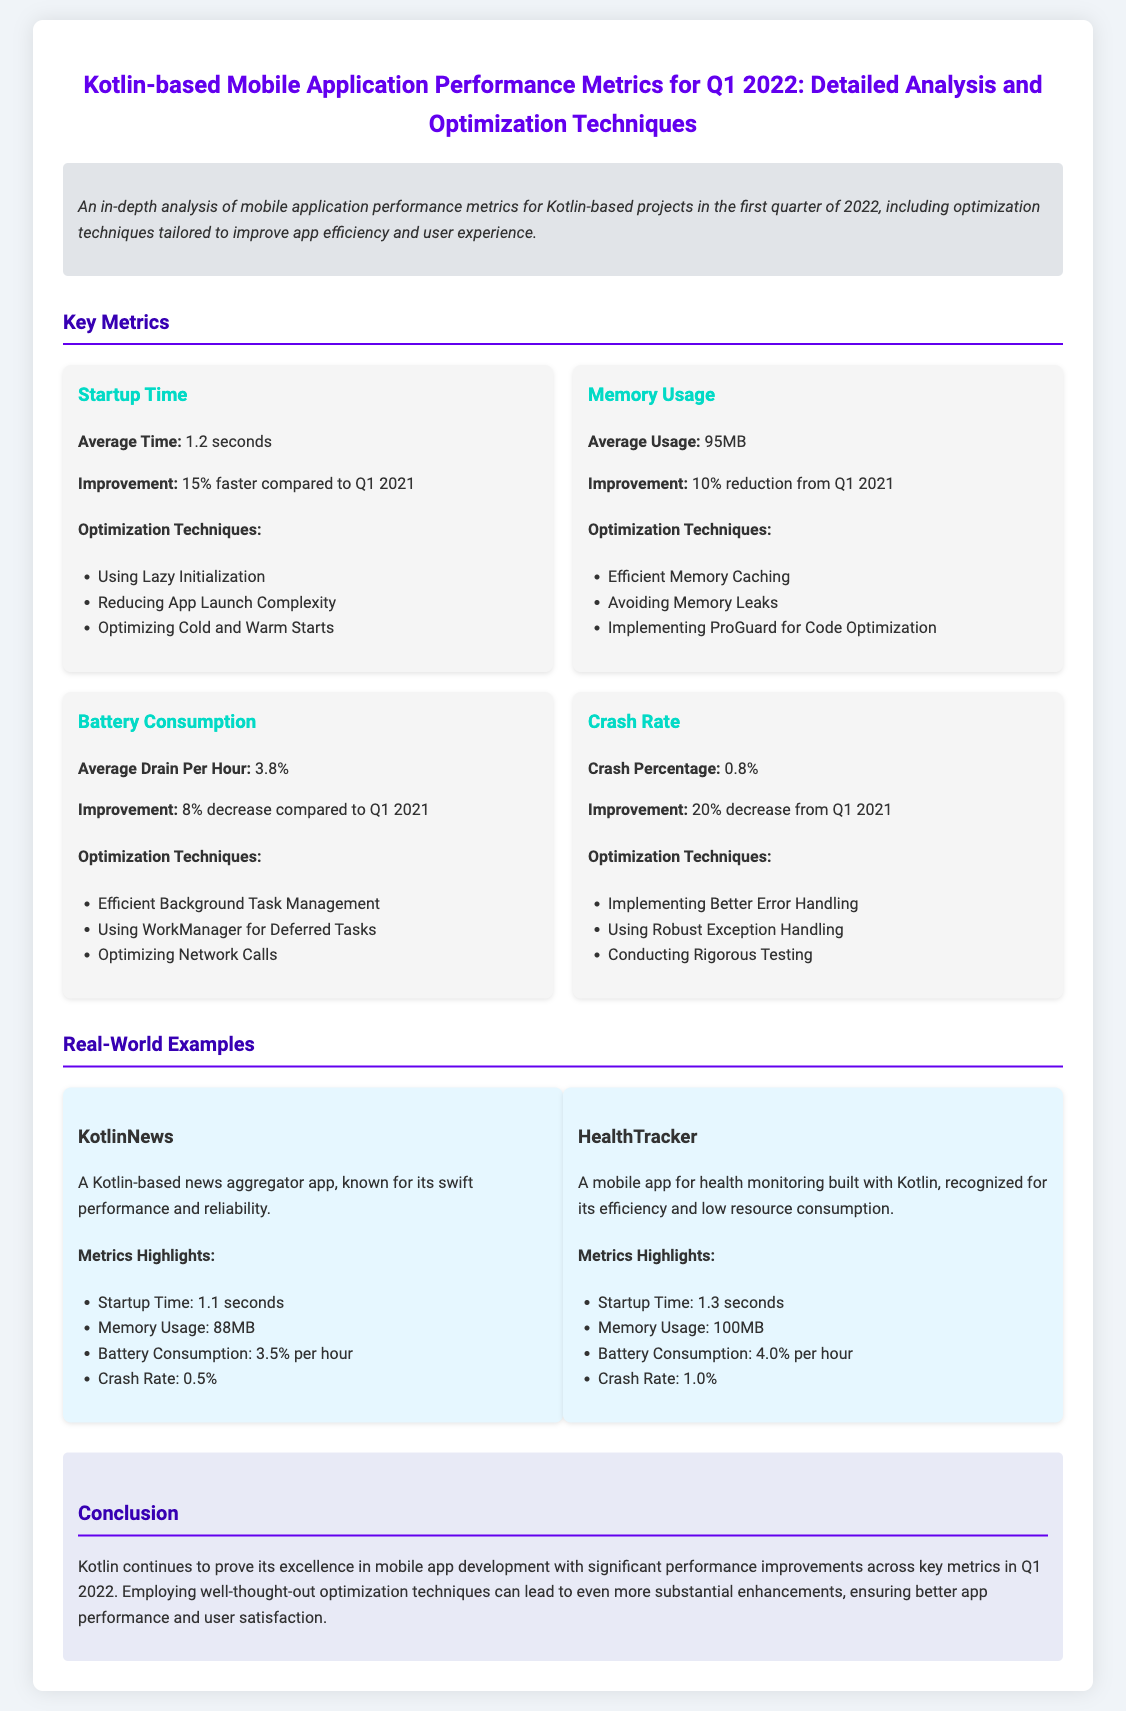What is the average startup time? The average startup time is mentioned in the metrics section of the document.
Answer: 1.2 seconds What is the improvement in memory usage? The document states that memory usage improved by a certain percentage compared to Q1 2021.
Answer: 10% reduction What is the crash percentage? The document lists the crash percentage as part of the performance metrics.
Answer: 0.8% What optimization technique is suggested for battery consumption? The document highlights several optimization techniques; one relates specifically to managing background tasks.
Answer: Efficient Background Task Management What are the metrics highlights for KotlinNews? The document provides a detailed overview of performance metrics for the app KotlinNews.
Answer: Startup Time: 1.1 seconds, Memory Usage: 88MB, Battery Consumption: 3.5% per hour, Crash Rate: 0.5% How much faster was the startup time compared to Q1 2021? The improvement in startup time compared to the previous year is explicitly stated in the document.
Answer: 15% faster What mobile app is known for low resource consumption? The document introduces several apps; one is recognized for efficiency and low resource usage.
Answer: HealthTracker What is the average battery consumption per hour? The battery consumption metric is noted in the performance metrics section of the document.
Answer: 3.8% What conclusion is drawn about Kotlin's performance in Q1 2022? The document summarizes the overall findings regarding Kotlin's performance in mobile app development.
Answer: Significant performance improvements across key metrics 